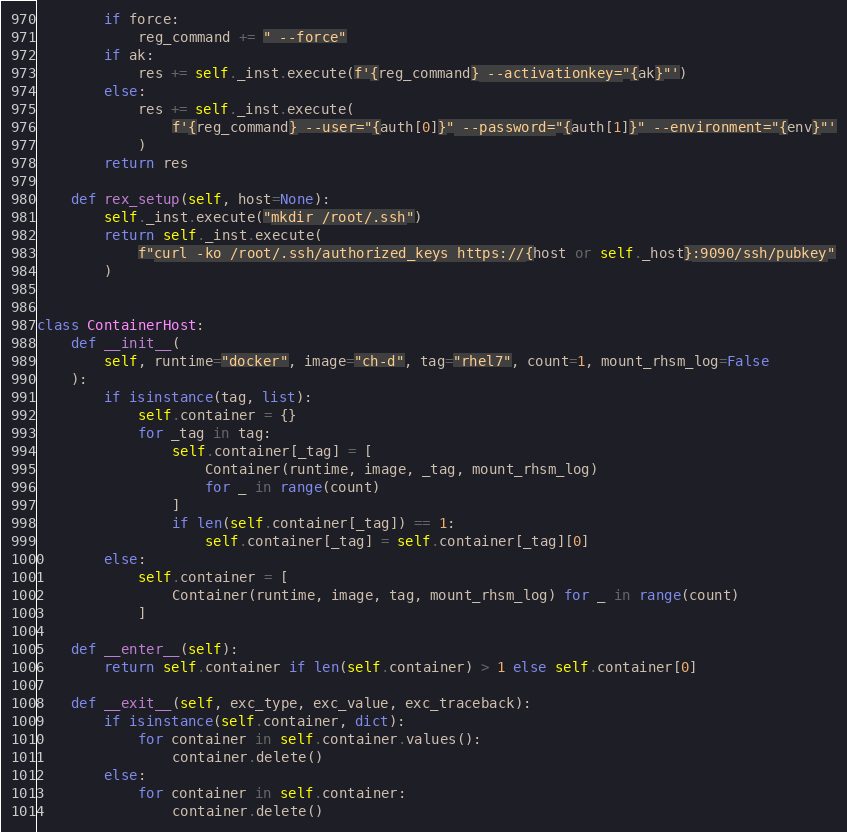<code> <loc_0><loc_0><loc_500><loc_500><_Python_>        if force:
            reg_command += " --force"
        if ak:
            res += self._inst.execute(f'{reg_command} --activationkey="{ak}"')
        else:
            res += self._inst.execute(
                f'{reg_command} --user="{auth[0]}" --password="{auth[1]}" --environment="{env}"'
            )
        return res

    def rex_setup(self, host=None):
        self._inst.execute("mkdir /root/.ssh")
        return self._inst.execute(
            f"curl -ko /root/.ssh/authorized_keys https://{host or self._host}:9090/ssh/pubkey"
        )


class ContainerHost:
    def __init__(
        self, runtime="docker", image="ch-d", tag="rhel7", count=1, mount_rhsm_log=False
    ):
        if isinstance(tag, list):
            self.container = {}
            for _tag in tag:
                self.container[_tag] = [
                    Container(runtime, image, _tag, mount_rhsm_log)
                    for _ in range(count)
                ]
                if len(self.container[_tag]) == 1:
                    self.container[_tag] = self.container[_tag][0]
        else:
            self.container = [
                Container(runtime, image, tag, mount_rhsm_log) for _ in range(count)
            ]

    def __enter__(self):
        return self.container if len(self.container) > 1 else self.container[0]

    def __exit__(self, exc_type, exc_value, exc_traceback):
        if isinstance(self.container, dict):
            for container in self.container.values():
                container.delete()
        else:
            for container in self.container:
                container.delete()
</code> 